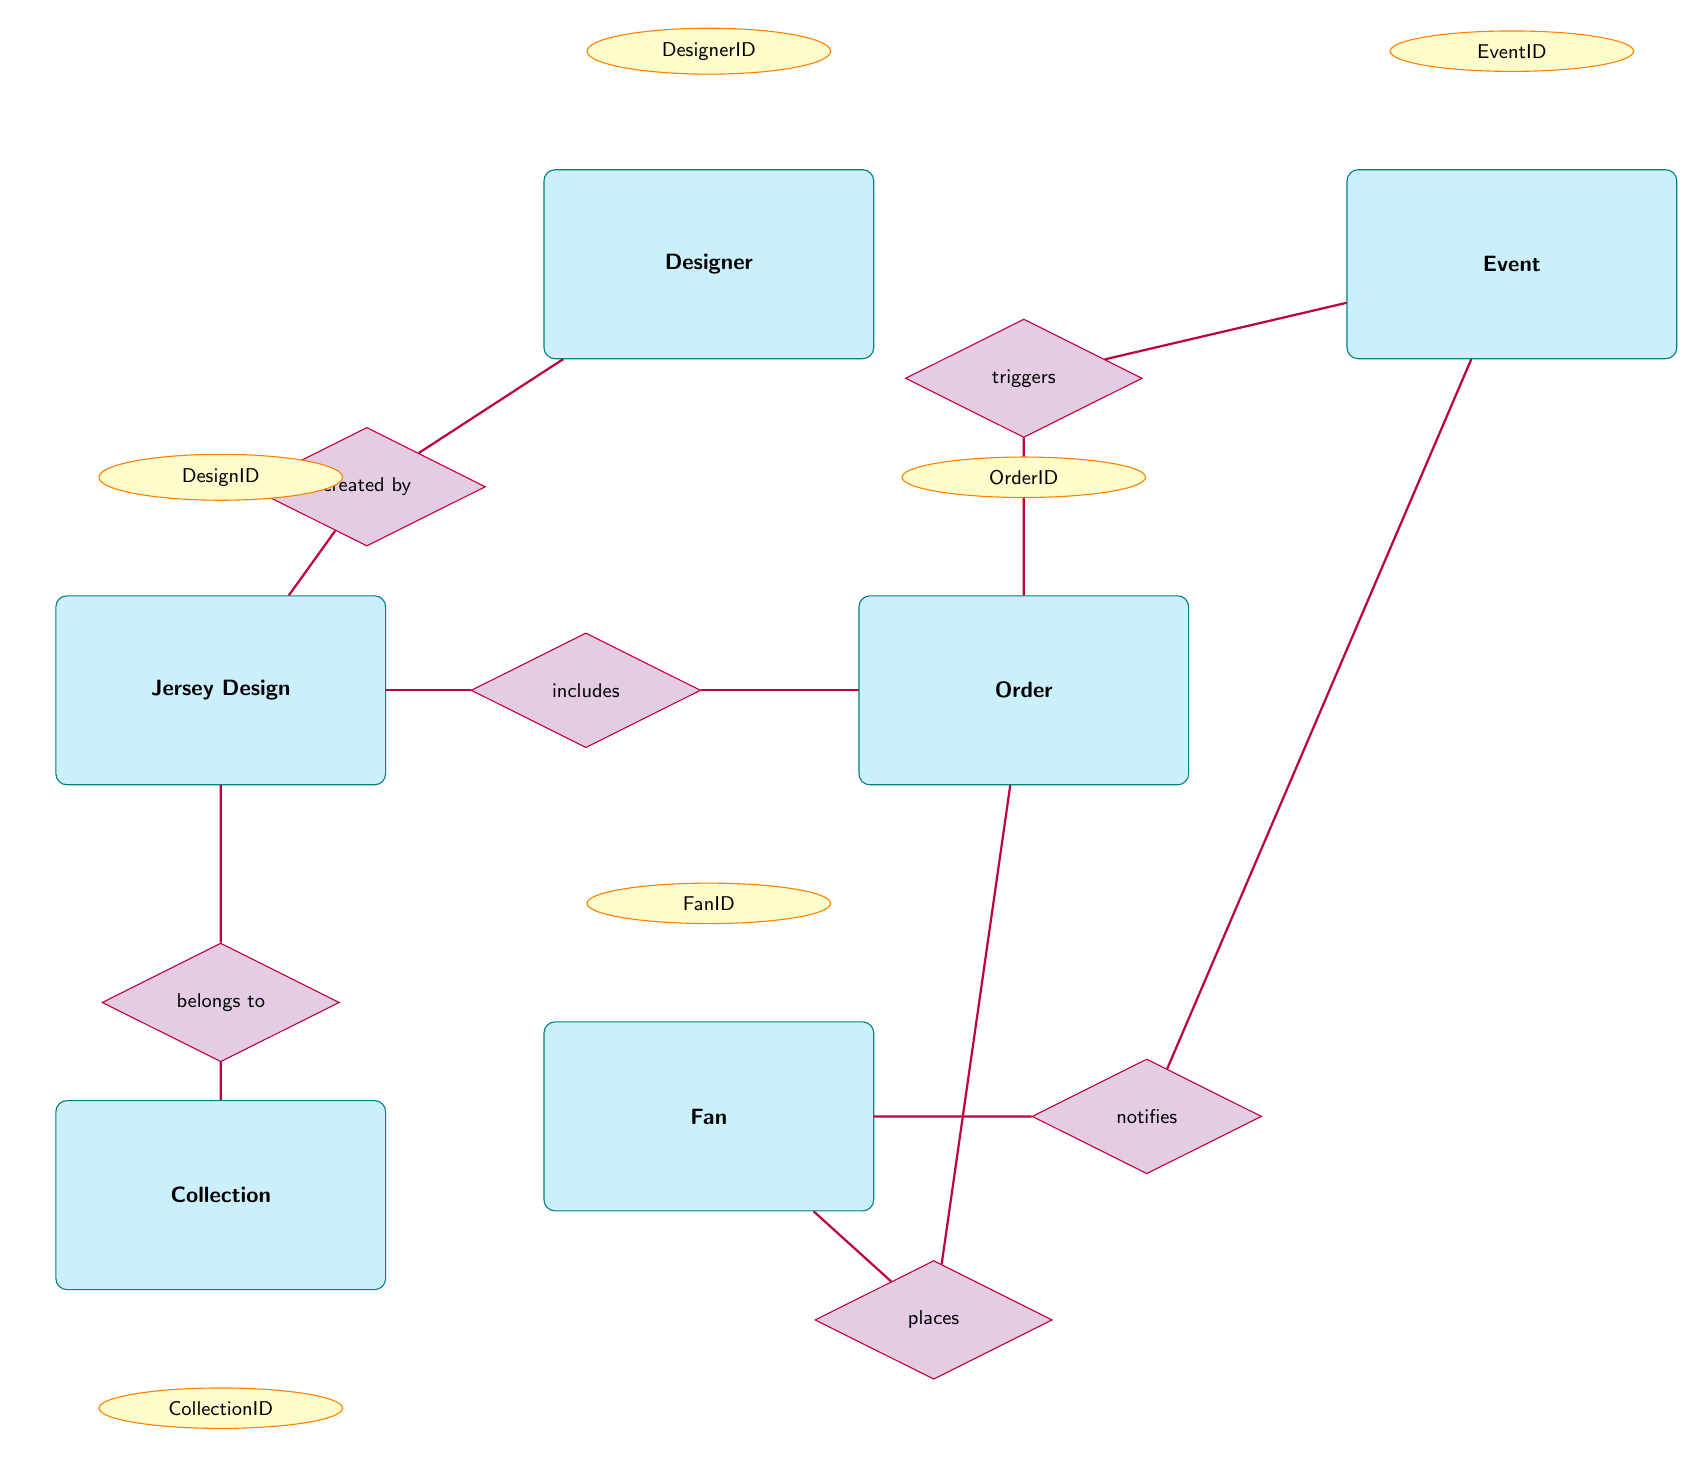What entity is created by the Designer? The diagram shows a relationship between the JerseyDesign entity and the Designer entity where JerseyDesign is created by Designer. This is indicated by the arrow pointing from the relationship "created by" to the Designer entity.
Answer: JerseyDesign How many attributes does the Fan entity have? By examining the Fan entity in the diagram, it can be seen that there are five attributes listed: FanID, Name, ContactInfo, PreferredTeam, and OrderHistory. Counting these gives a total of five attributes.
Answer: 5 What relationship exists between Order and JerseyDesign? The diagram indicates a relationship where an Order includes a JerseyDesign, as represented by the relationship labeled "includes" which connects the Order and JerseyDesign entities.
Answer: includes Which entity is notified about the Event? The diagram highlights a relationship where the Fan entity receives notifications about events, shown by the "notifies" relationship connecting the Event and Fan entities.
Answer: Fan What is the relationship between Event and Order? The diagram displays a relationship where the Event triggers an Order, indicated by the "triggers" relationship which connects the Event entity to the Order entity.
Answer: triggers How many total nodes are depicted in this ER diagram? Counting all the entities visible in the diagram: JerseyDesign, Designer, Fan, Order, Event, and Collection results in a total of six nodes.
Answer: 6 Which entity does the JerseyDesign belong to? From the diagram, it is shown that the JerseyDesign belongs to a Collection, established by the relationship labeled "belongs to" connecting JerseyDesign and Collection.
Answer: Collection What type of information does the attribute 'FabricType' belong to? In the diagram, FabricType is listed as one of the attributes under the JerseyDesign entity, indicating that it is information pertaining specifically to JerseyDesign.
Answer: JerseyDesign What is the Theme related to in the Collection entity? The Collection entity has a specific attribute labeled Theme, which refers to the thematic design aspect of the Collection. Thus, Theme is directly related to Collection.
Answer: Collection 